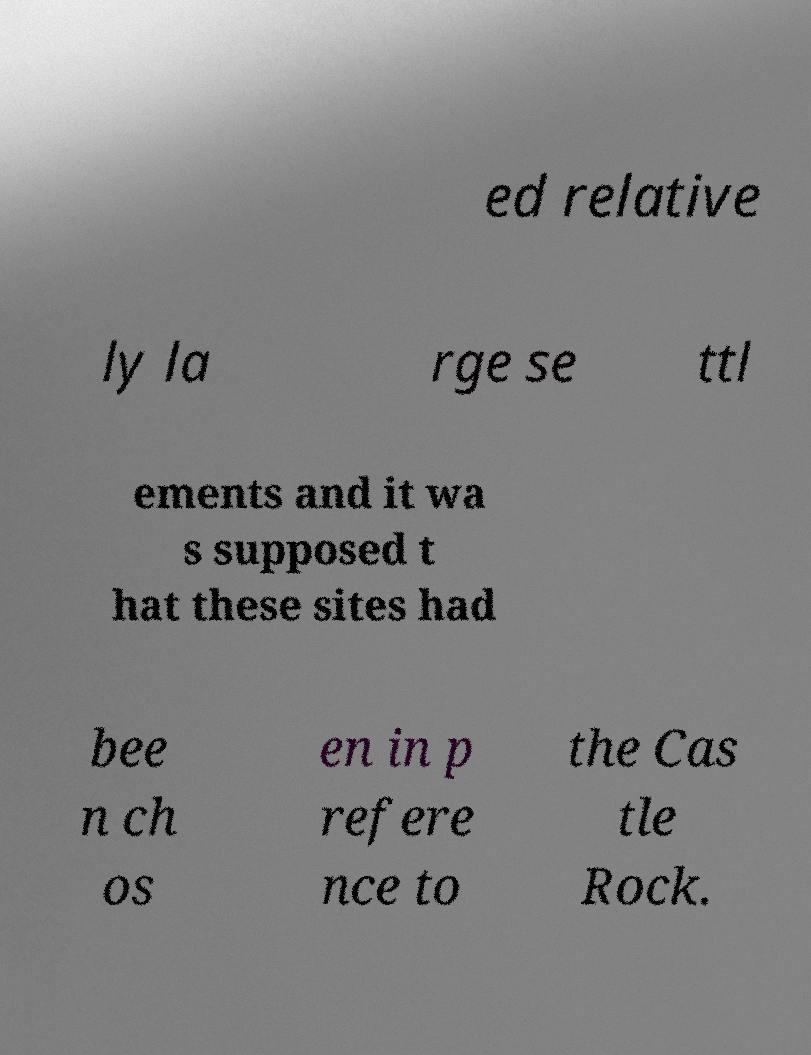Please read and relay the text visible in this image. What does it say? ed relative ly la rge se ttl ements and it wa s supposed t hat these sites had bee n ch os en in p refere nce to the Cas tle Rock. 